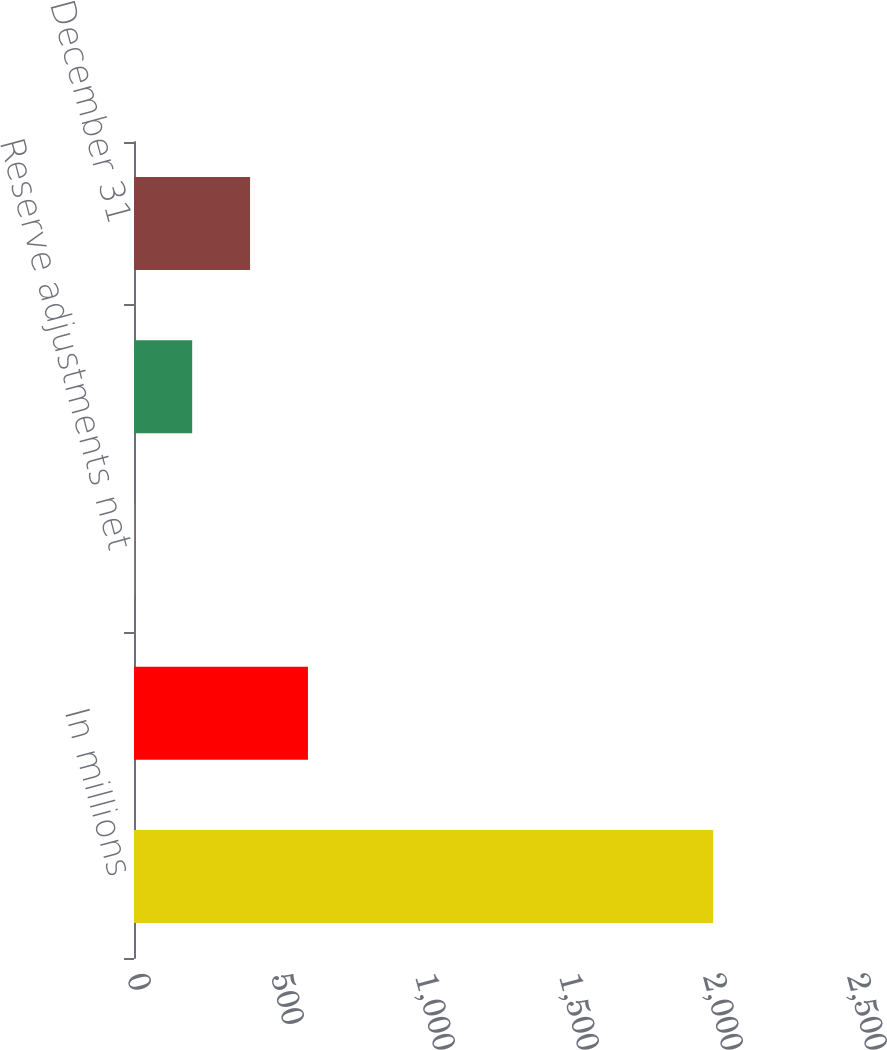Convert chart to OTSL. <chart><loc_0><loc_0><loc_500><loc_500><bar_chart><fcel>In millions<fcel>January 1<fcel>Reserve adjustments net<fcel>Losses - loan repurchases and<fcel>December 31<nl><fcel>2011<fcel>604<fcel>1<fcel>202<fcel>403<nl></chart> 